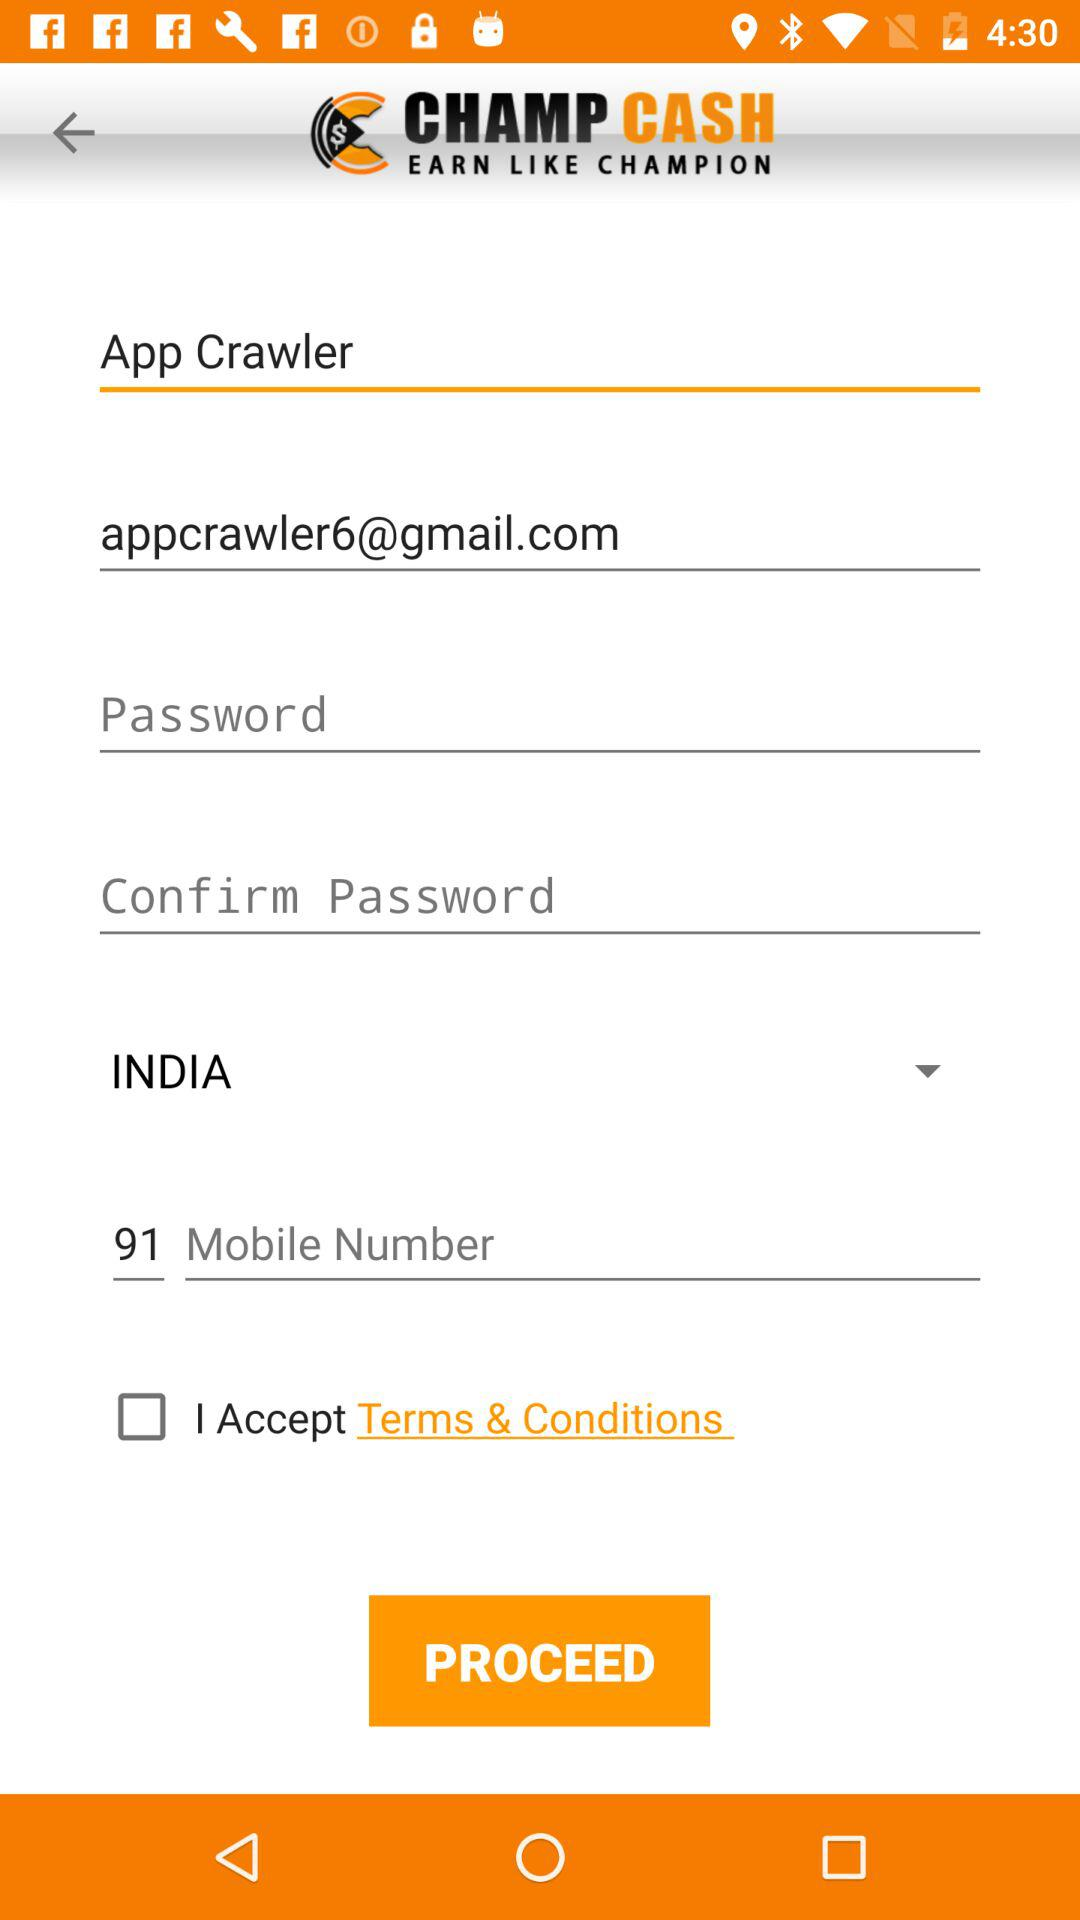What is the name of the user? The name of the user is App Crawler. 